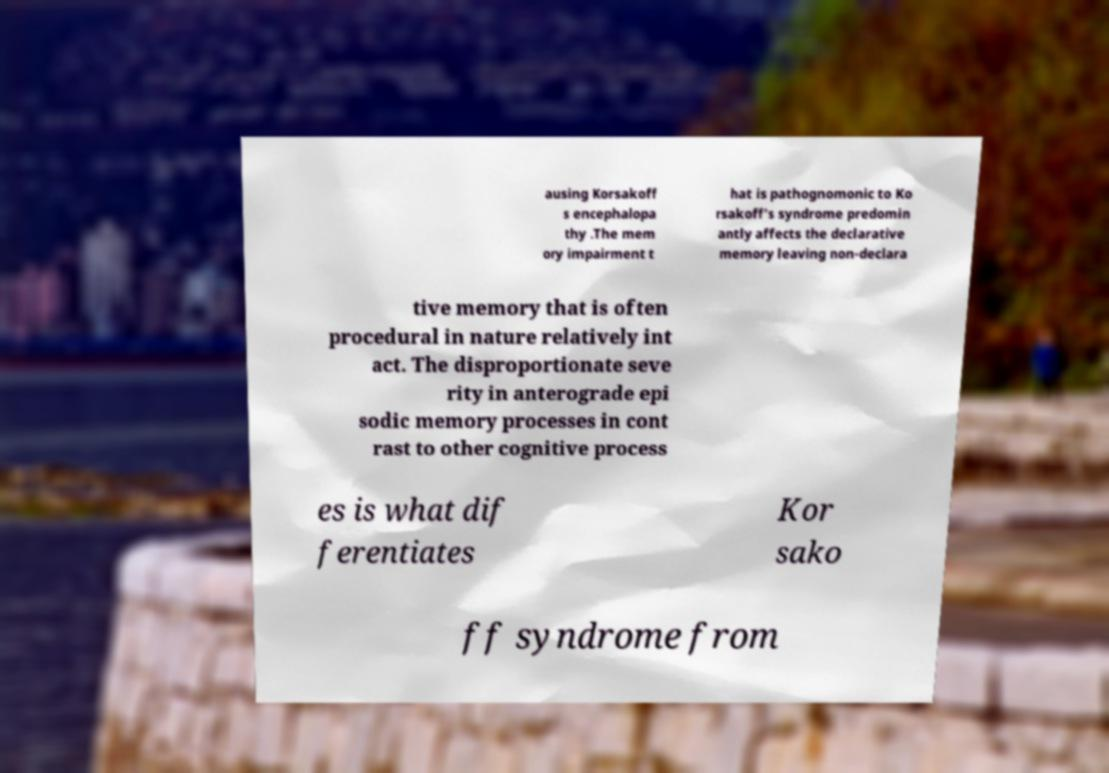Can you read and provide the text displayed in the image?This photo seems to have some interesting text. Can you extract and type it out for me? ausing Korsakoff s encephalopa thy .The mem ory impairment t hat is pathognomonic to Ko rsakoff's syndrome predomin antly affects the declarative memory leaving non-declara tive memory that is often procedural in nature relatively int act. The disproportionate seve rity in anterograde epi sodic memory processes in cont rast to other cognitive process es is what dif ferentiates Kor sako ff syndrome from 